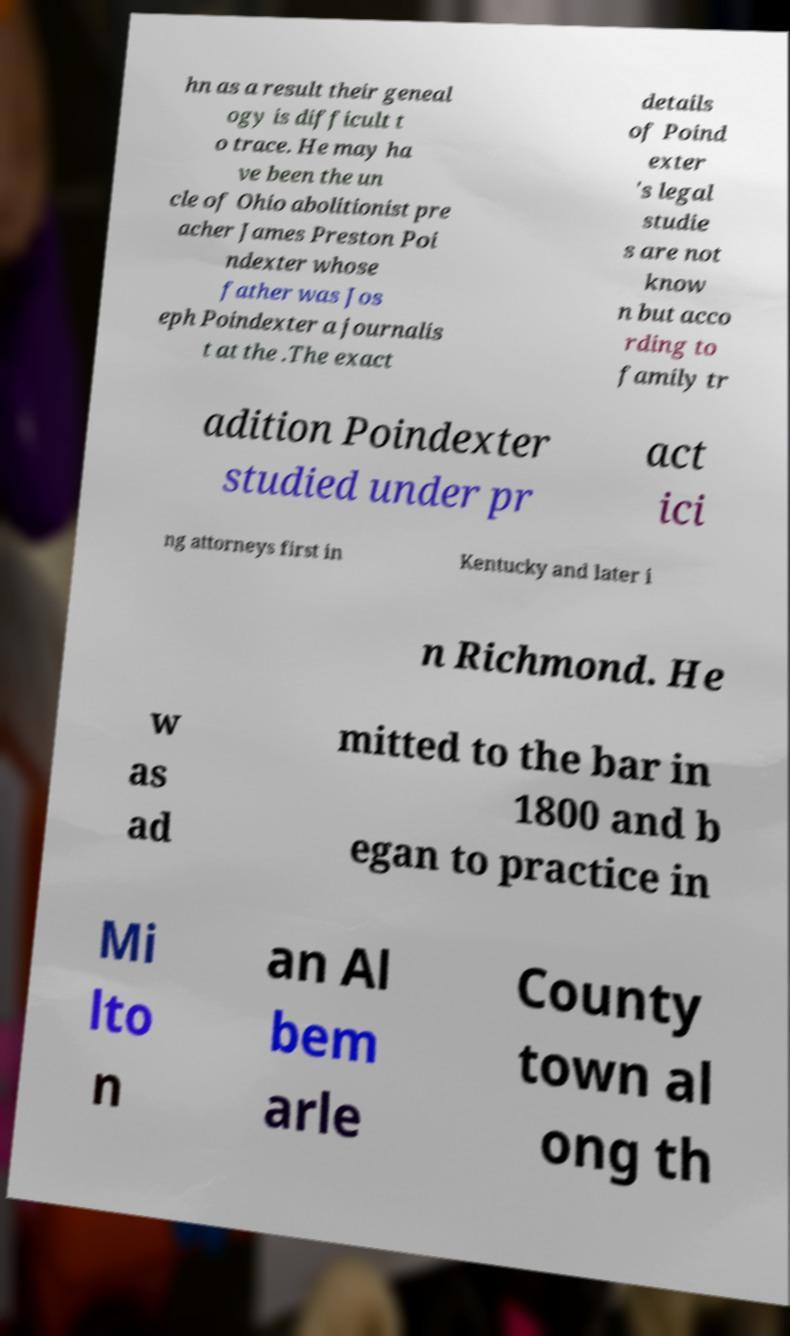Could you assist in decoding the text presented in this image and type it out clearly? hn as a result their geneal ogy is difficult t o trace. He may ha ve been the un cle of Ohio abolitionist pre acher James Preston Poi ndexter whose father was Jos eph Poindexter a journalis t at the .The exact details of Poind exter 's legal studie s are not know n but acco rding to family tr adition Poindexter studied under pr act ici ng attorneys first in Kentucky and later i n Richmond. He w as ad mitted to the bar in 1800 and b egan to practice in Mi lto n an Al bem arle County town al ong th 